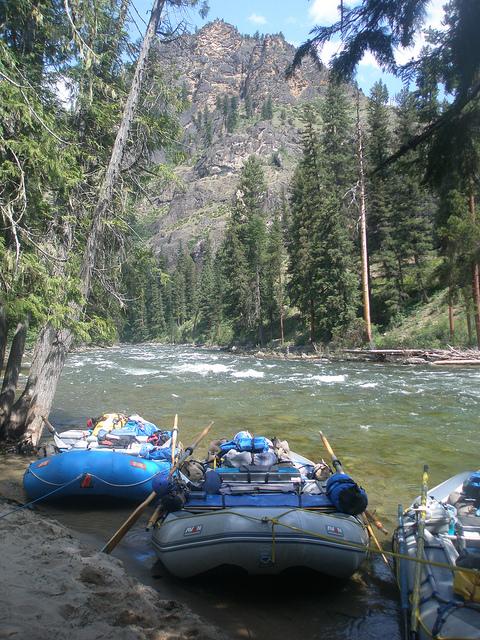How many boats are near the river?
Short answer required. 3. How many boats are about to get in the water?
Answer briefly. 3. Is this boat going to carry a lot of people?
Keep it brief. No. 